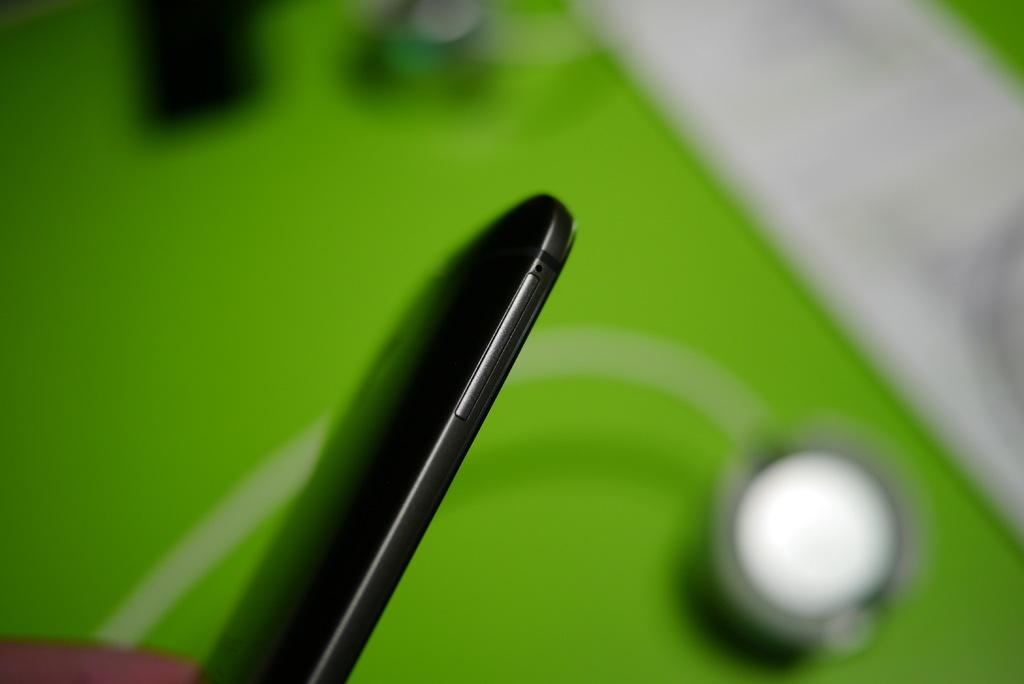What electronic device is visible in the image? There is a mobile phone in the image. Can you describe the appearance of the mobile phone? The provided facts do not include a description of the mobile phone's appearance. What might someone be doing with the mobile phone in the image? The provided facts do not indicate what someone might be doing with the mobile phone. What type of cobweb can be seen in the image? There is no cobweb present in the image; it features a mobile phone. 